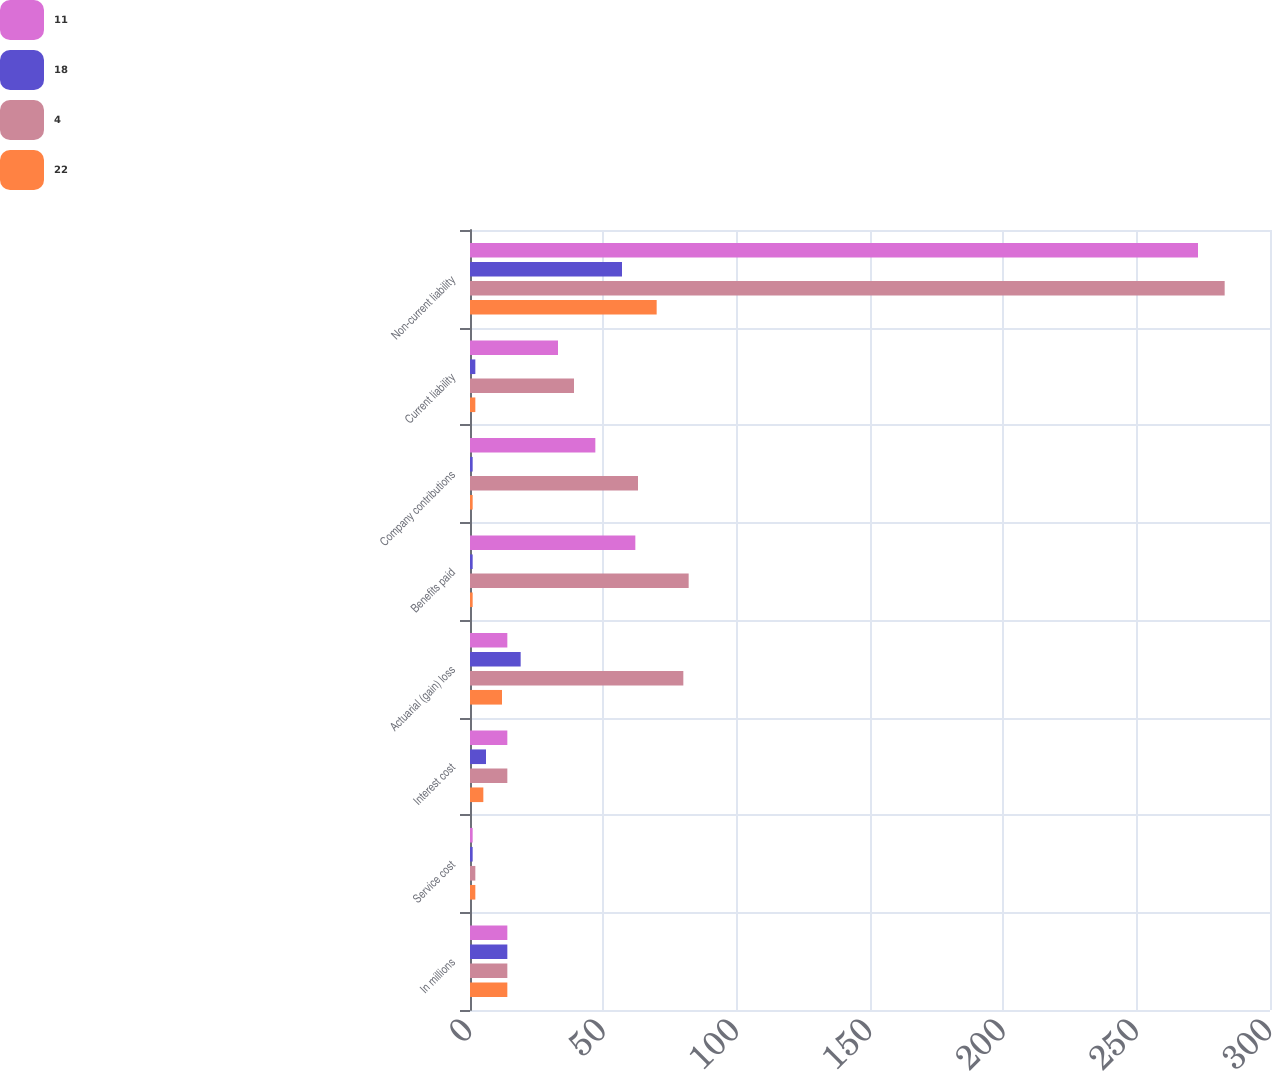<chart> <loc_0><loc_0><loc_500><loc_500><stacked_bar_chart><ecel><fcel>In millions<fcel>Service cost<fcel>Interest cost<fcel>Actuarial (gain) loss<fcel>Benefits paid<fcel>Company contributions<fcel>Current liability<fcel>Non-current liability<nl><fcel>11<fcel>14<fcel>1<fcel>14<fcel>14<fcel>62<fcel>47<fcel>33<fcel>273<nl><fcel>18<fcel>14<fcel>1<fcel>6<fcel>19<fcel>1<fcel>1<fcel>2<fcel>57<nl><fcel>4<fcel>14<fcel>2<fcel>14<fcel>80<fcel>82<fcel>63<fcel>39<fcel>283<nl><fcel>22<fcel>14<fcel>2<fcel>5<fcel>12<fcel>1<fcel>1<fcel>2<fcel>70<nl></chart> 